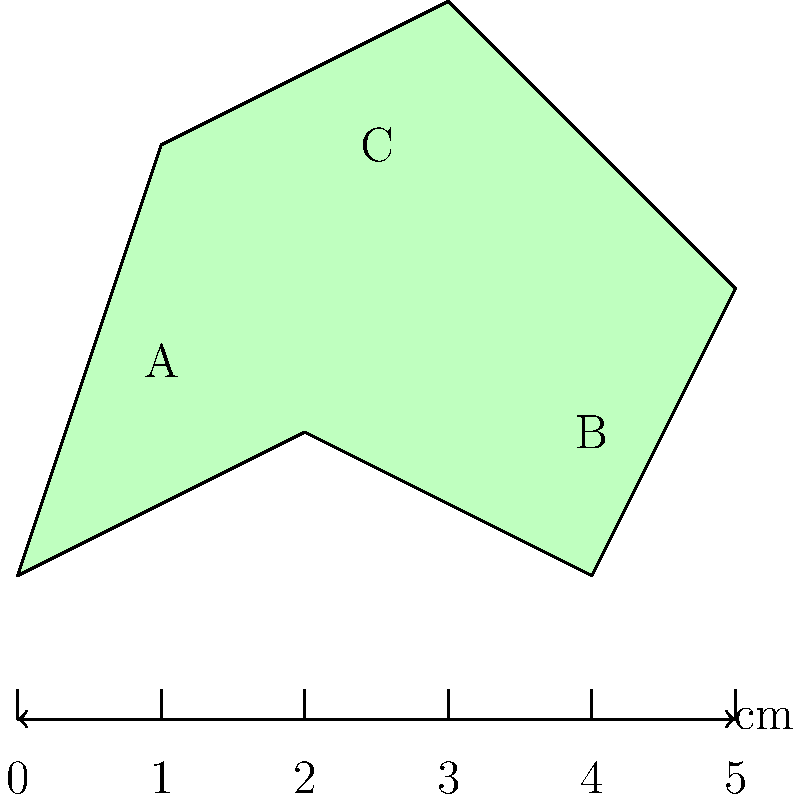You are examining a rare historical document from the Reformation era. The document has an irregular shape, as shown in the diagram. Using the ruler for scale (in cm), calculate the approximate area of the document using the method of dividing it into triangles. Round your answer to the nearest square centimeter. To calculate the area of this irregular shape, we'll divide it into three triangles: ABC, ACD, and ABD.

1. Calculate the base and height of each triangle:
   Triangle ABC: base ≈ 4 cm, height ≈ 3 cm
   Triangle ACD: base ≈ 2 cm, height ≈ 3 cm
   Triangle ABD: base ≈ 5 cm, height ≈ 2 cm

2. Use the formula for the area of a triangle: $A = \frac{1}{2} \times base \times height$

3. Calculate the area of each triangle:
   ABC: $A_{ABC} = \frac{1}{2} \times 4 \times 3 = 6$ cm²
   ACD: $A_{ACD} = \frac{1}{2} \times 2 \times 3 = 3$ cm²
   ABD: $A_{ABD} = \frac{1}{2} \times 5 \times 2 = 5$ cm²

4. Sum up the areas of all triangles:
   $A_{total} = A_{ABC} + A_{ACD} + A_{ABD} = 6 + 3 + 5 = 14$ cm²

Therefore, the approximate area of the historical document is 14 square centimeters.
Answer: 14 cm² 